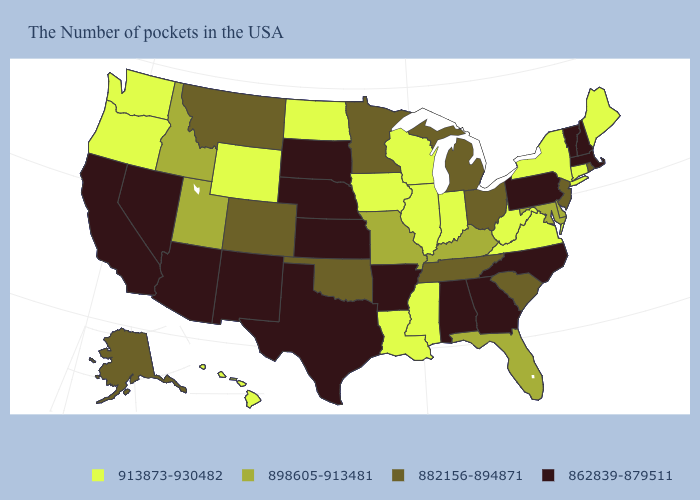Name the states that have a value in the range 862839-879511?
Concise answer only. Massachusetts, New Hampshire, Vermont, Pennsylvania, North Carolina, Georgia, Alabama, Arkansas, Kansas, Nebraska, Texas, South Dakota, New Mexico, Arizona, Nevada, California. Does Connecticut have the highest value in the USA?
Quick response, please. Yes. What is the highest value in states that border Maine?
Answer briefly. 862839-879511. Does West Virginia have the highest value in the South?
Keep it brief. Yes. What is the value of Connecticut?
Keep it brief. 913873-930482. Does the map have missing data?
Keep it brief. No. What is the value of California?
Short answer required. 862839-879511. What is the value of Delaware?
Keep it brief. 898605-913481. What is the value of Illinois?
Quick response, please. 913873-930482. What is the value of Massachusetts?
Write a very short answer. 862839-879511. Name the states that have a value in the range 862839-879511?
Write a very short answer. Massachusetts, New Hampshire, Vermont, Pennsylvania, North Carolina, Georgia, Alabama, Arkansas, Kansas, Nebraska, Texas, South Dakota, New Mexico, Arizona, Nevada, California. Among the states that border Massachusetts , does Connecticut have the lowest value?
Give a very brief answer. No. What is the value of South Carolina?
Quick response, please. 882156-894871. What is the highest value in states that border New Mexico?
Keep it brief. 898605-913481. Which states have the lowest value in the USA?
Answer briefly. Massachusetts, New Hampshire, Vermont, Pennsylvania, North Carolina, Georgia, Alabama, Arkansas, Kansas, Nebraska, Texas, South Dakota, New Mexico, Arizona, Nevada, California. 